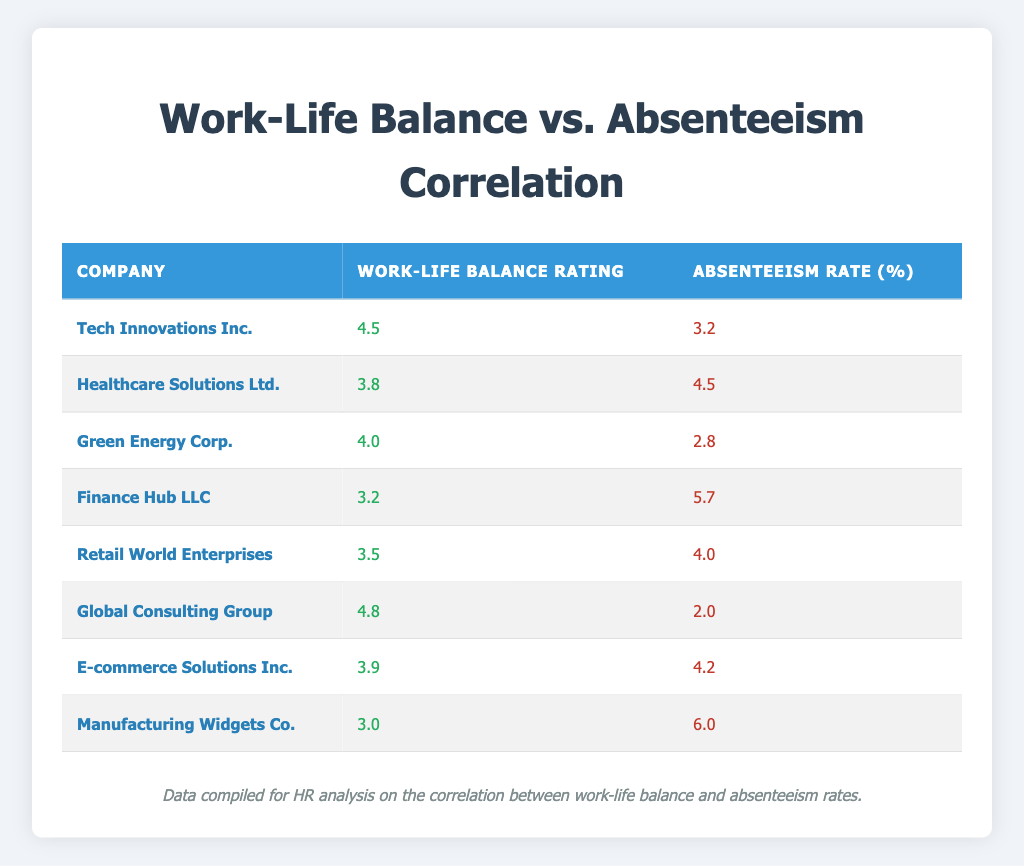What is the Work-Life Balance Rating for Global Consulting Group? By looking at the table, Global Consulting Group's Work-Life Balance Rating is listed in the second column next to its company name. It shows a rating of 4.8.
Answer: 4.8 Which company has the highest Absenteeism Rate? The highest Absenteeism Rate can be found by reviewing the values in the third column. The company with the highest rate is Manufacturing Widgets Co., which has an Absenteeism Rate of 6.0.
Answer: Manufacturing Widgets Co What is the average Work-Life Balance Rating of all companies listed? To find the average Work-Life Balance Rating, sum all the ratings: 4.5 + 3.8 + 4.0 + 3.2 + 3.5 + 4.8 + 3.9 + 3.0 = 30.7. There are 8 companies, so the average is 30.7 / 8 = 3.8375, which rounds to 3.84.
Answer: 3.84 Is there a correlation where higher Work-Life Balance Ratings result in lower Absenteeism Rates? This question requires examining the relationship between the columns. By comparing values, companies like Global Consulting Group and Tech Innovations Inc. with higher ratings have lower absenteeism, while companies with lower ratings like Finance Hub LLC and Manufacturing Widgets Co. have higher absenteeism. This suggests a potential negative correlation.
Answer: Yes How do the Absenteeism Rates compare between the companies with the top two Work-Life Balance Ratings? The two companies with the highest ratings are Global Consulting Group (4.8) and Tech Innovations Inc. (4.5). Their Absenteeism Rates are 2.0 and 3.2, respectively. The difference is 3.2 - 2.0 = 1.2, indicating that a higher rating corresponds to a lower absenteeism rate.
Answer: 1.2 What percentage of companies have an Absenteeism Rate above 4%? Out of eight companies, four have Absenteeism Rates above 4% (Healthcare Solutions Ltd., Finance Hub LLC, Retail World Enterprises, and E-commerce Solutions Inc.). Therefore, 4 out of 8 is 50%.
Answer: 50% Does Healthcare Solutions Ltd. have a lower Work-Life Balance Rating than Retail World Enterprises? Looking at the ratings, Healthcare Solutions Ltd. has a Work-Life Balance Rating of 3.8, while Retail World Enterprises has a rating of 3.5. This means Healthcare Solutions Ltd. has a higher rating than Retail World Enterprises, hence the answer is false.
Answer: No What is the combined Absenteeism Rate of the companies with a rating below 4? The companies with a rating below 4 are Finance Hub LLC (5.7), Retail World Enterprises (4.0), and Manufacturing Widgets Co. (6.0). Thus, the combined rate is 5.7 + 4.0 + 6.0 = 15.7.
Answer: 15.7 